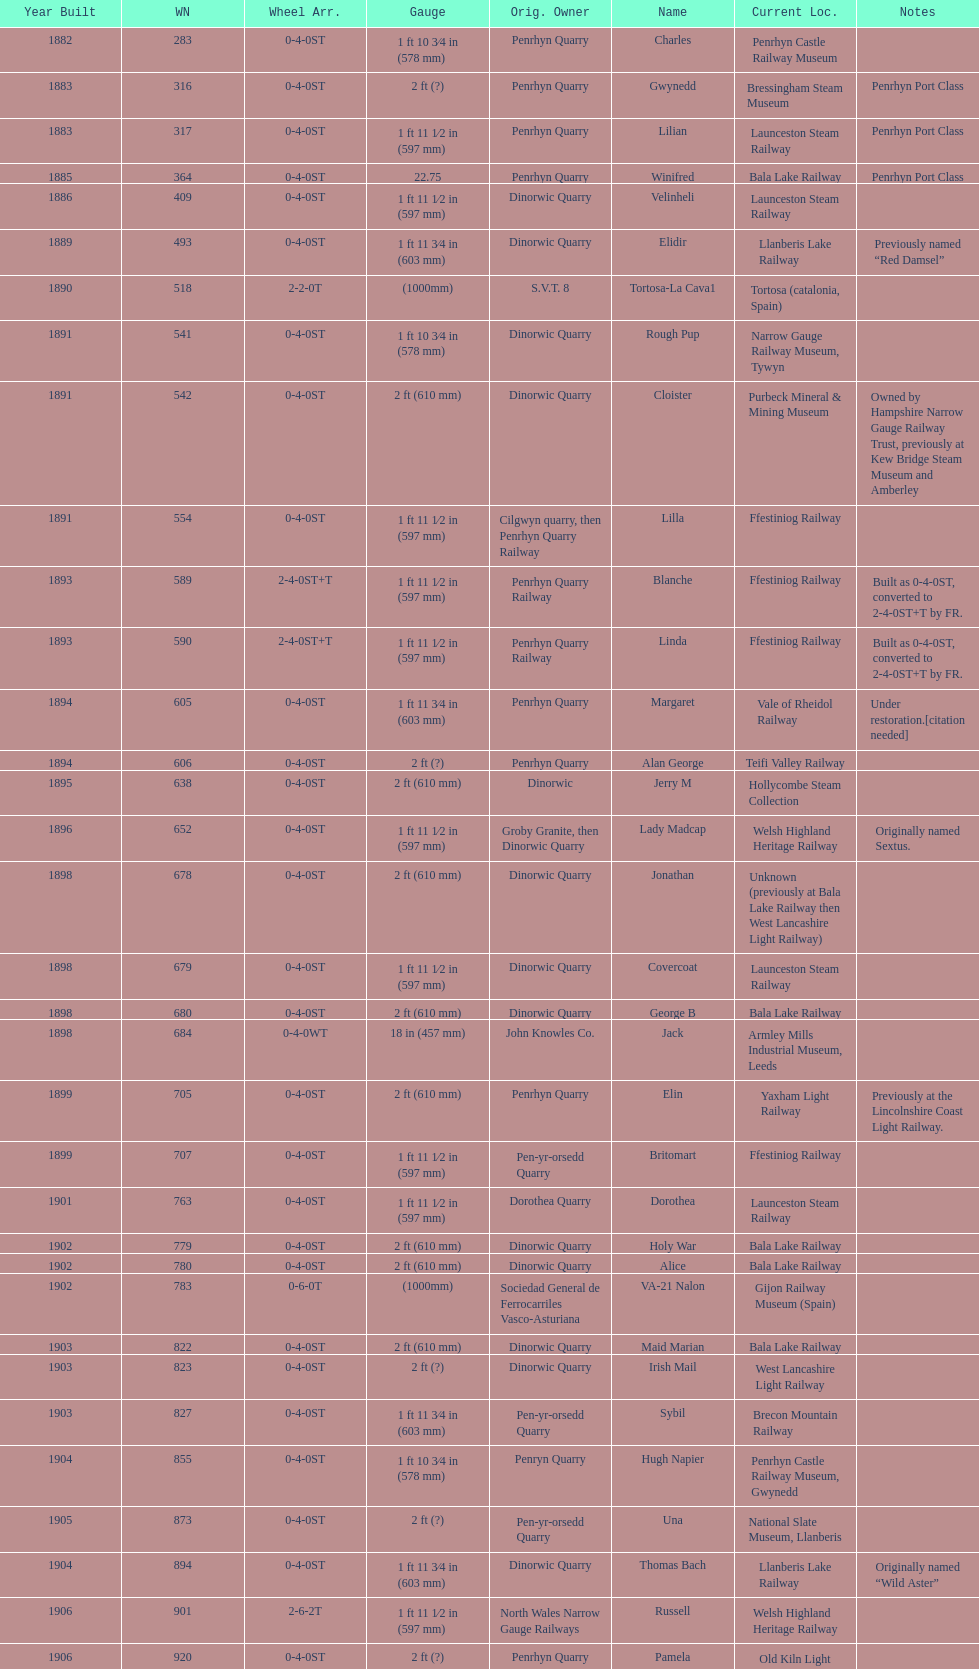After 1940, how many steam locomotives were built? 2. 